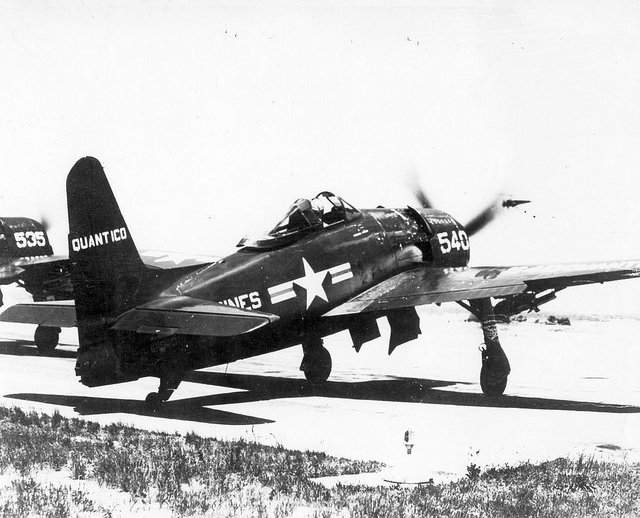Describe the objects in this image and their specific colors. I can see airplane in whitesmoke, black, gray, lightgray, and darkgray tones, airplane in whitesmoke, black, gray, lightgray, and darkgray tones, people in whitesmoke, black, gray, darkgray, and lightgray tones, and people in whitesmoke, white, black, gray, and darkgray tones in this image. 